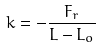Convert formula to latex. <formula><loc_0><loc_0><loc_500><loc_500>k = - \frac { F _ { r } } { L - L _ { o } }</formula> 